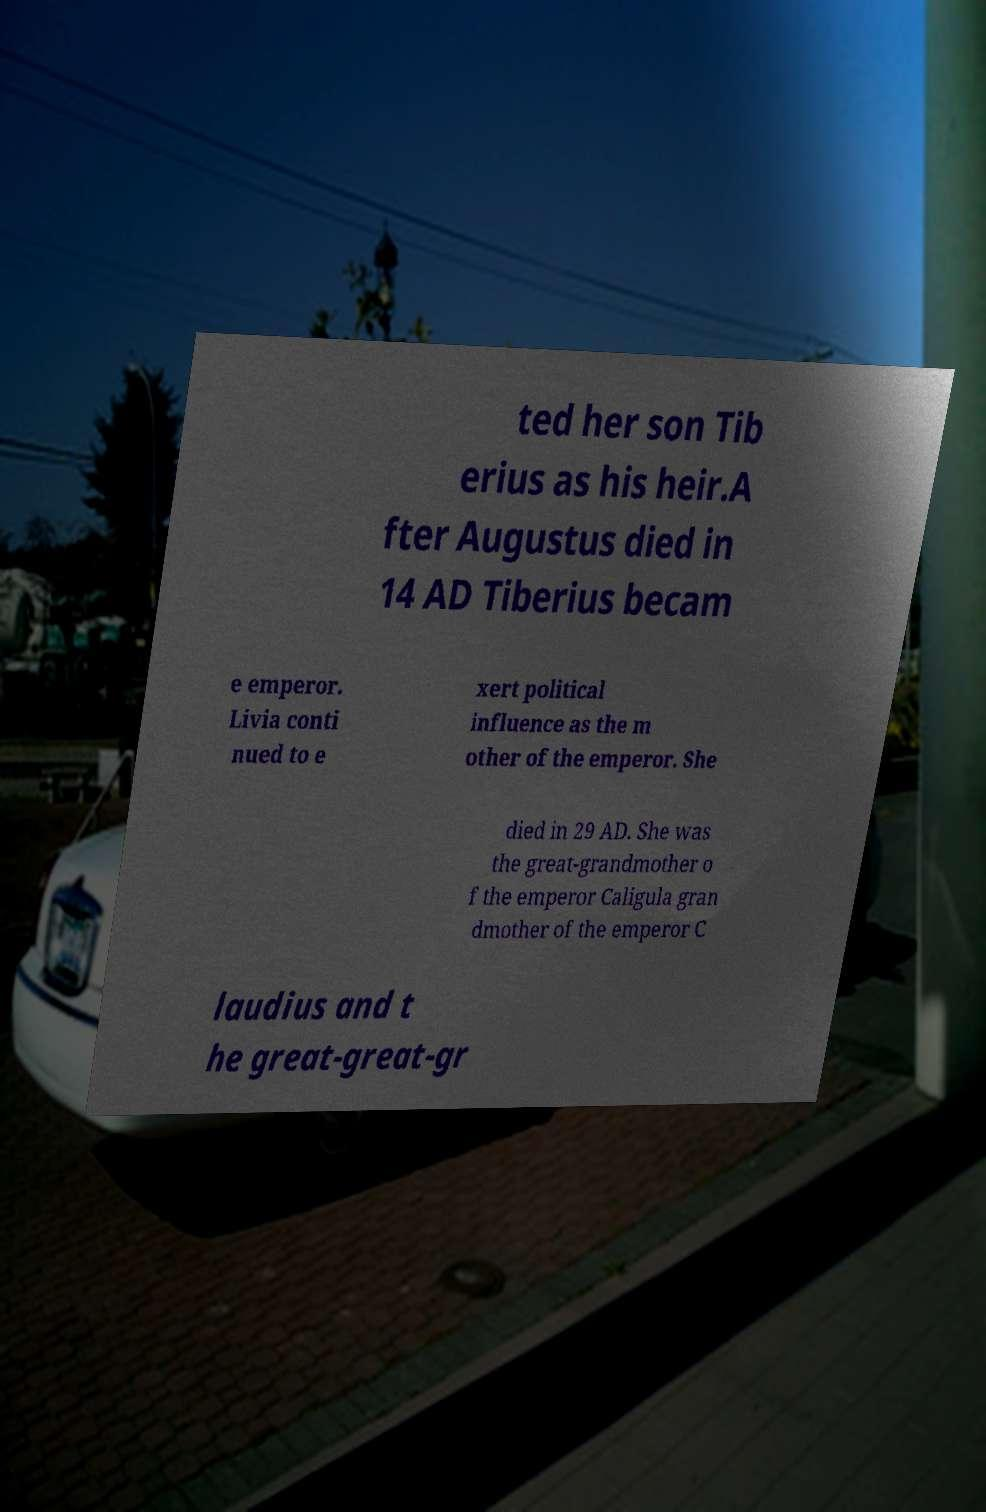Can you accurately transcribe the text from the provided image for me? ted her son Tib erius as his heir.A fter Augustus died in 14 AD Tiberius becam e emperor. Livia conti nued to e xert political influence as the m other of the emperor. She died in 29 AD. She was the great-grandmother o f the emperor Caligula gran dmother of the emperor C laudius and t he great-great-gr 